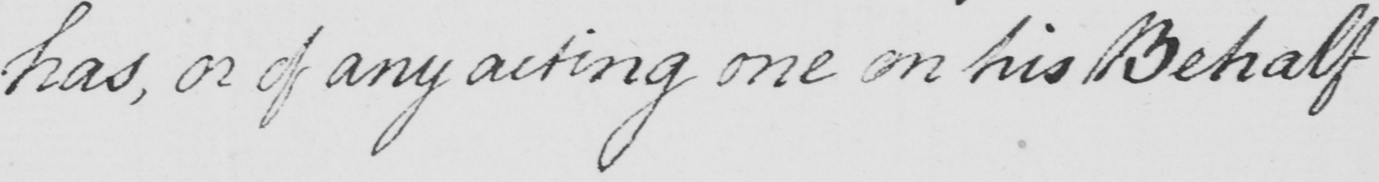Please provide the text content of this handwritten line. has , or of any acting one on his Behalf 